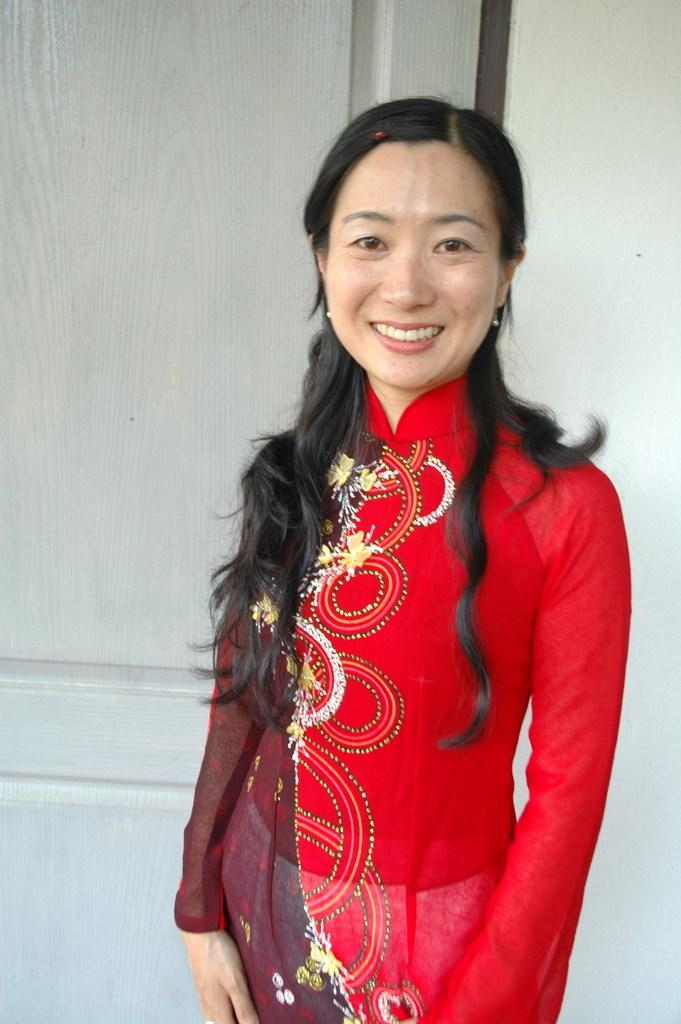What can be seen in the background of the image? There is a wall visible in the background of the image, and a partial part of a door is present. Who is in the image? There is a woman standing in the image. What is the woman doing in the image? The woman is smiling. Is the woman swimming in the image? No, there is no indication of swimming in the image; the woman is standing and smiling. 